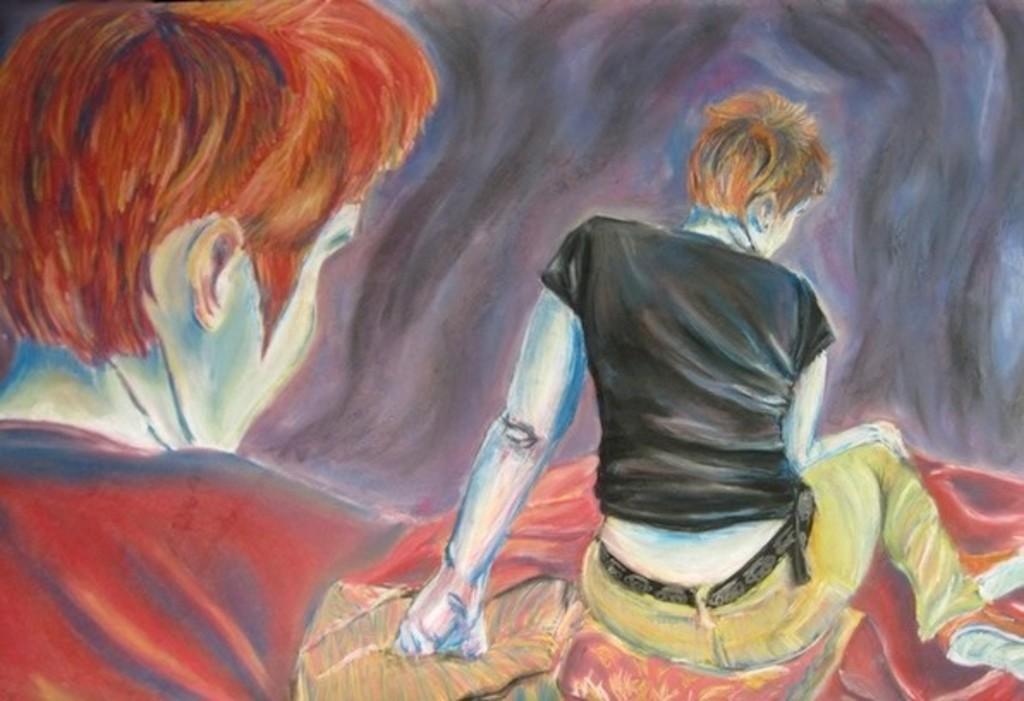In one or two sentences, can you explain what this image depicts? In the image we can see the painting. In the painting we can see two people wearing clothes. 